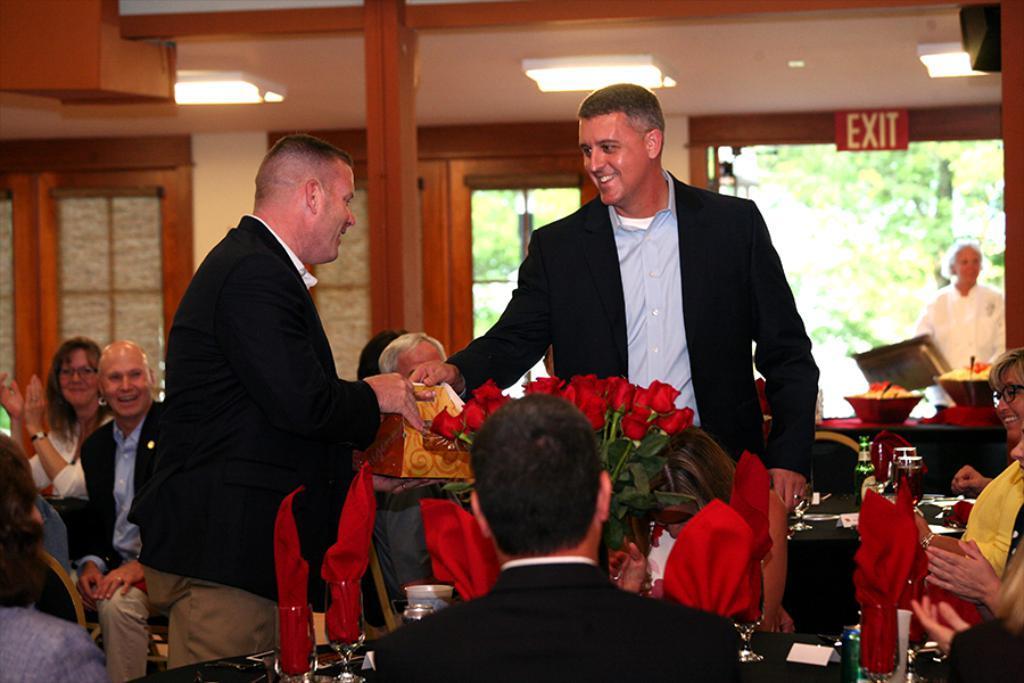Could you give a brief overview of what you see in this image? In the center of the image there are persons standing on the floor. At the bottom of the image we can see flower vase and persons sitting at the table. In the background we can see tables, beverages, bottles, plates, persons, door, windows, lights and wall. 